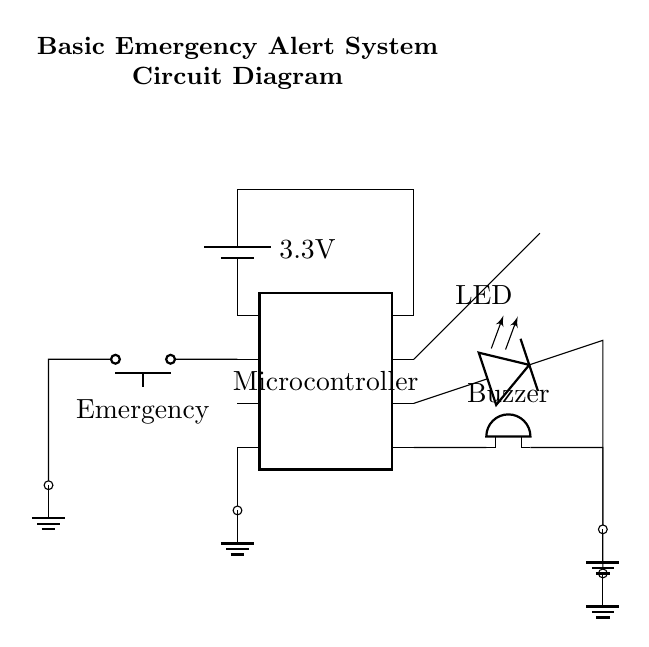What is the main power supply voltage for this circuit? The circuit uses a 3.3V battery connected to the microcontroller, which indicates that this is the main supply voltage for the operation of the circuit.
Answer: 3.3V What component is responsible for sound output in this circuit? The component labeled as "Buzzer" is directly connected to pin 5 of the microcontroller, indicating that it is responsible for sound output when activated.
Answer: Buzzer Which pin of the microcontroller is connected to the emergency button? The emergency button is connected to pin 2 of the microcontroller, which is essential for triggering the alert system.
Answer: pin 2 What does the LED indicate in this circuit? The LED is connected to pin 6 of the microcontroller, suggesting it is used as an indicator (likely to show the status of the alert, such as activation or standby).
Answer: Indicator If the emergency button is pressed, what component is activated? Pressing the emergency button sends a signal to the microcontroller, which likely activates the buzzer (since it is connected through the microcontroller's control logic) as part of the alert system.
Answer: Buzzer What connectivity exists between the microcontroller and the antenna? The antenna is connected directly to pin 7 of the microcontroller, which is used for transmitting alerts wirelessly, demonstrating a direct connection.
Answer: Direct connection How many pins does the microcontroller have in total? The diagram indicates that the microcontroller has 8 pins, as noted by the 'num pins=8' label in the circuit diagram.
Answer: 8 pins 